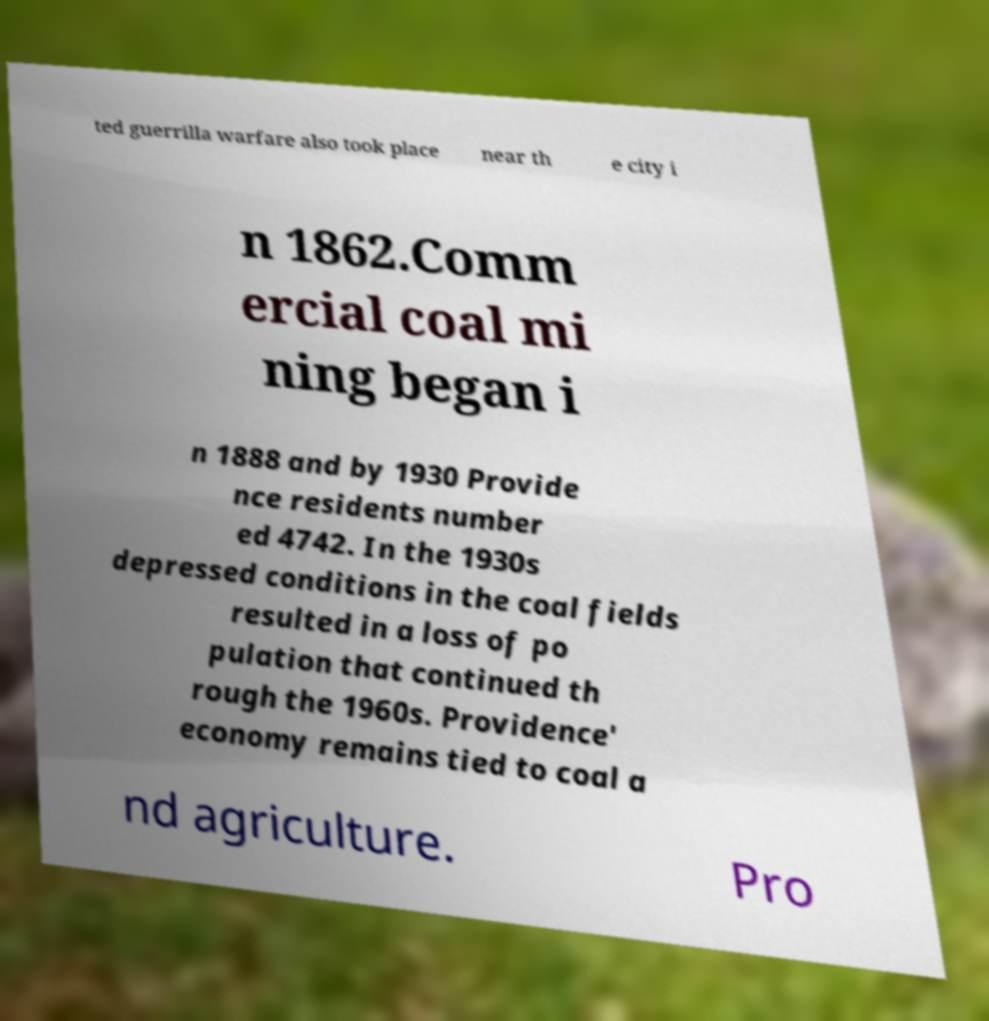Could you assist in decoding the text presented in this image and type it out clearly? ted guerrilla warfare also took place near th e city i n 1862.Comm ercial coal mi ning began i n 1888 and by 1930 Provide nce residents number ed 4742. In the 1930s depressed conditions in the coal fields resulted in a loss of po pulation that continued th rough the 1960s. Providence' economy remains tied to coal a nd agriculture. Pro 